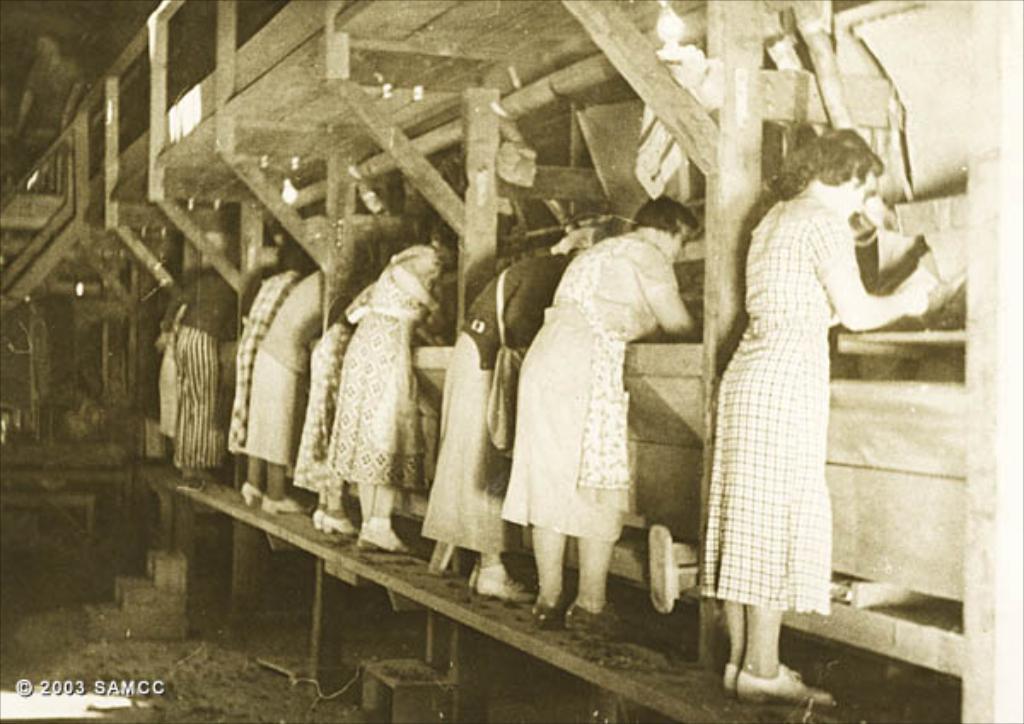Please provide a concise description of this image. This is a black and white picture. In this picture, we see many people are standing. In front of them, we see the wooden walls and poles. On the left side, we see the staircase. We see the man is standing. At the top, we see the roof of the building and we even see the lights. This picture might be clicked in the stable. 